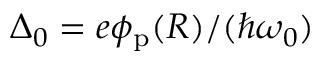Convert formula to latex. <formula><loc_0><loc_0><loc_500><loc_500>\Delta _ { 0 } = e \phi _ { p } ( R ) / ( \hbar { \omega } _ { 0 } )</formula> 